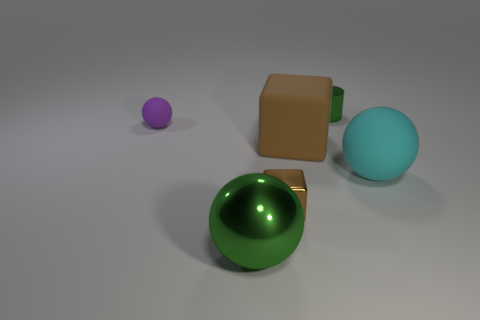There is a large object that is the same color as the cylinder; what is its shape?
Give a very brief answer. Sphere. How many shiny things have the same shape as the large cyan rubber object?
Keep it short and to the point. 1. Is the number of big rubber blocks behind the small metal cylinder less than the number of cylinders behind the metal ball?
Your answer should be compact. Yes. There is a cyan ball; is its size the same as the green thing that is left of the small cylinder?
Offer a terse response. Yes. What number of purple matte objects have the same size as the cyan object?
Ensure brevity in your answer.  0. How many tiny things are metallic things or metallic cubes?
Your response must be concise. 2. Is there a green cylinder?
Ensure brevity in your answer.  Yes. Is the number of small objects in front of the big brown block greater than the number of brown metallic objects that are on the left side of the green metallic ball?
Ensure brevity in your answer.  Yes. There is a matte ball that is on the right side of the big sphere that is in front of the cyan rubber object; what color is it?
Make the answer very short. Cyan. Are there any other cylinders of the same color as the small cylinder?
Provide a succinct answer. No. 